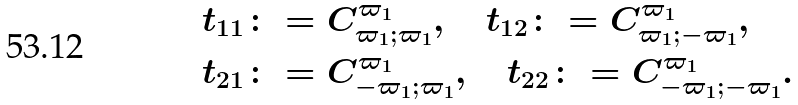<formula> <loc_0><loc_0><loc_500><loc_500>& t _ { 1 1 } \colon = C _ { \varpi _ { 1 } ; \varpi _ { 1 } } ^ { \varpi _ { 1 } } , \quad t _ { 1 2 } \colon = C _ { \varpi _ { 1 } ; - \varpi _ { 1 } } ^ { \varpi _ { 1 } } , \\ & t _ { 2 1 } \colon = C _ { - \varpi _ { 1 } ; \varpi _ { 1 } } ^ { \varpi _ { 1 } } , \quad t _ { 2 2 } \colon = C _ { - \varpi _ { 1 } ; - \varpi _ { 1 } } ^ { \varpi _ { 1 } } .</formula> 